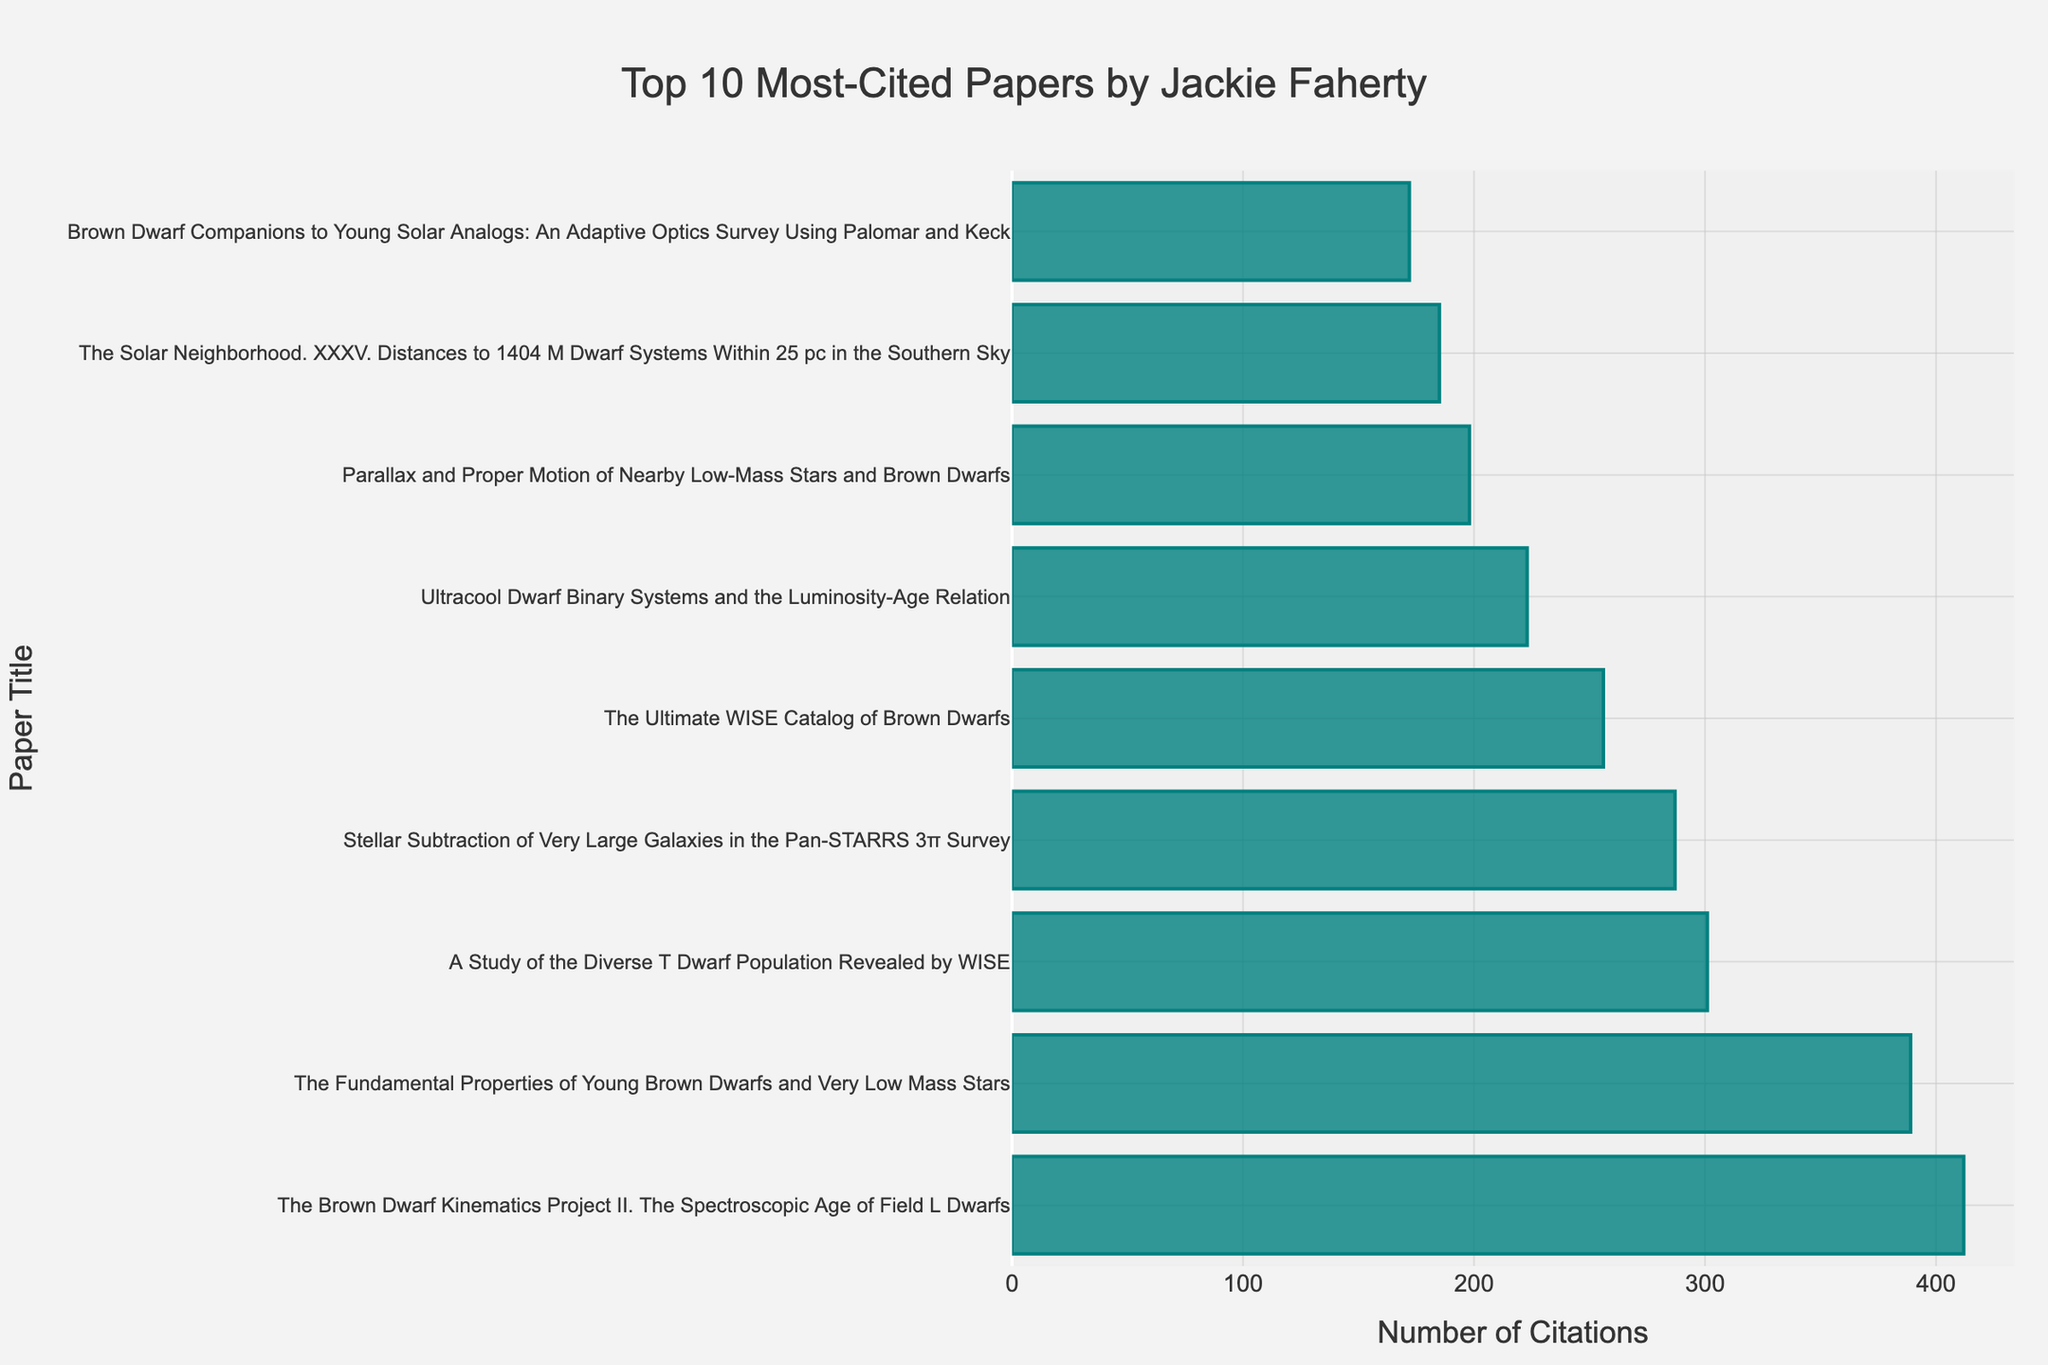Which paper has the highest number of citations? The bar representing "The Brown Dwarf Kinematics Project II. The Spectroscopic Age of Field L Dwarfs" is the longest, indicating it has the highest number of citations.
Answer: "The Brown Dwarf Kinematics Project II. The Spectroscopic Age of Field L Dwarfs" Which paper has fewer citations, "The Ultimate WISE Catalog of Brown Dwarfs" or "Brown Dwarf Companions to Young Solar Analogs"? By comparing the lengths of the bars, "Brown Dwarf Companions to Young Solar Analogs" has a shorter bar than "The Ultimate WISE Catalog of Brown Dwarfs".
Answer: "Brown Dwarf Companions to Young Solar Analogs" What is the combined citation count of the top two most-cited papers? The top two most-cited papers are "The Brown Dwarf Kinematics Project II. The Spectroscopic Age of Field L Dwarfs" (412 citations) and "The Fundamental Properties of Young Brown Dwarfs and Very Low Mass Stars" (389 citations). Their combined count is 412 + 389 = 801.
Answer: 801 Which paper has the median number of citations? Sorting the citations in descending order, the fifth paper will be the median in a list of 9. So "The Ultimate WISE Catalog of Brown Dwarfs" is the median paper.
Answer: "The Ultimate WISE Catalog of Brown Dwarfs" What is the average number of citations for these top 10 papers? Sum all the citations: 412 + 389 + 301 + 287 + 256 + 223 + 198 + 185 + 172 = 2423. There are 9 papers, so the average is 2423 / 9 = 269.22.
Answer: 269.22 By how many citations does "A Study of the Diverse T Dwarf Population Revealed by WISE" exceed "Parallax and Proper Motion of Nearby Low-Mass Stars and Brown Dwarfs"? "A Study of the Diverse T Dwarf Population Revealed by WISE" has 301 citations, and "Parallax and Proper Motion of Nearby Low-Mass Stars and Brown Dwarfs" has 198 citations. The difference is 301 - 198 = 103.
Answer: 103 Which paper ranks third in terms of citations? By looking at the descending order of the bars, "A Study of the Diverse T Dwarf Population Revealed by WISE" is the third paper.
Answer: "A Study of the Diverse T Dwarf Population Revealed by WISE" What is the range of citations across these papers? The paper with the highest number of citations has 412, and the one with the fewest has 172. The range is 412 - 172 = 240.
Answer: 240 What is the ratio of citations between the most-cited paper and the least-cited paper? The most-cited paper has 412 citations and the least-cited one has 172. The ratio is 412 / 172 ≈ 2.40.
Answer: 2.40 